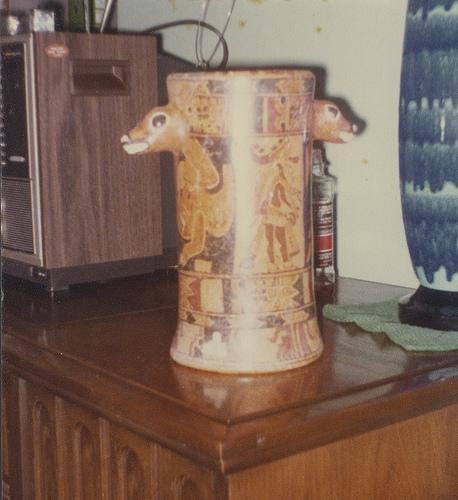How many animal heads are on the vase?
Give a very brief answer. 2. How many tvs are in the picture?
Give a very brief answer. 1. How many vases are there?
Give a very brief answer. 2. How many women are wearing blue sweaters?
Give a very brief answer. 0. 